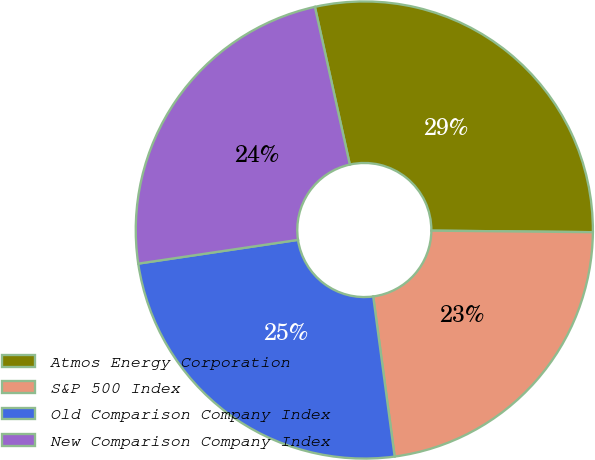<chart> <loc_0><loc_0><loc_500><loc_500><pie_chart><fcel>Atmos Energy Corporation<fcel>S&P 500 Index<fcel>Old Comparison Company Index<fcel>New Comparison Company Index<nl><fcel>28.62%<fcel>22.73%<fcel>24.77%<fcel>23.88%<nl></chart> 